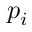Convert formula to latex. <formula><loc_0><loc_0><loc_500><loc_500>p _ { i }</formula> 